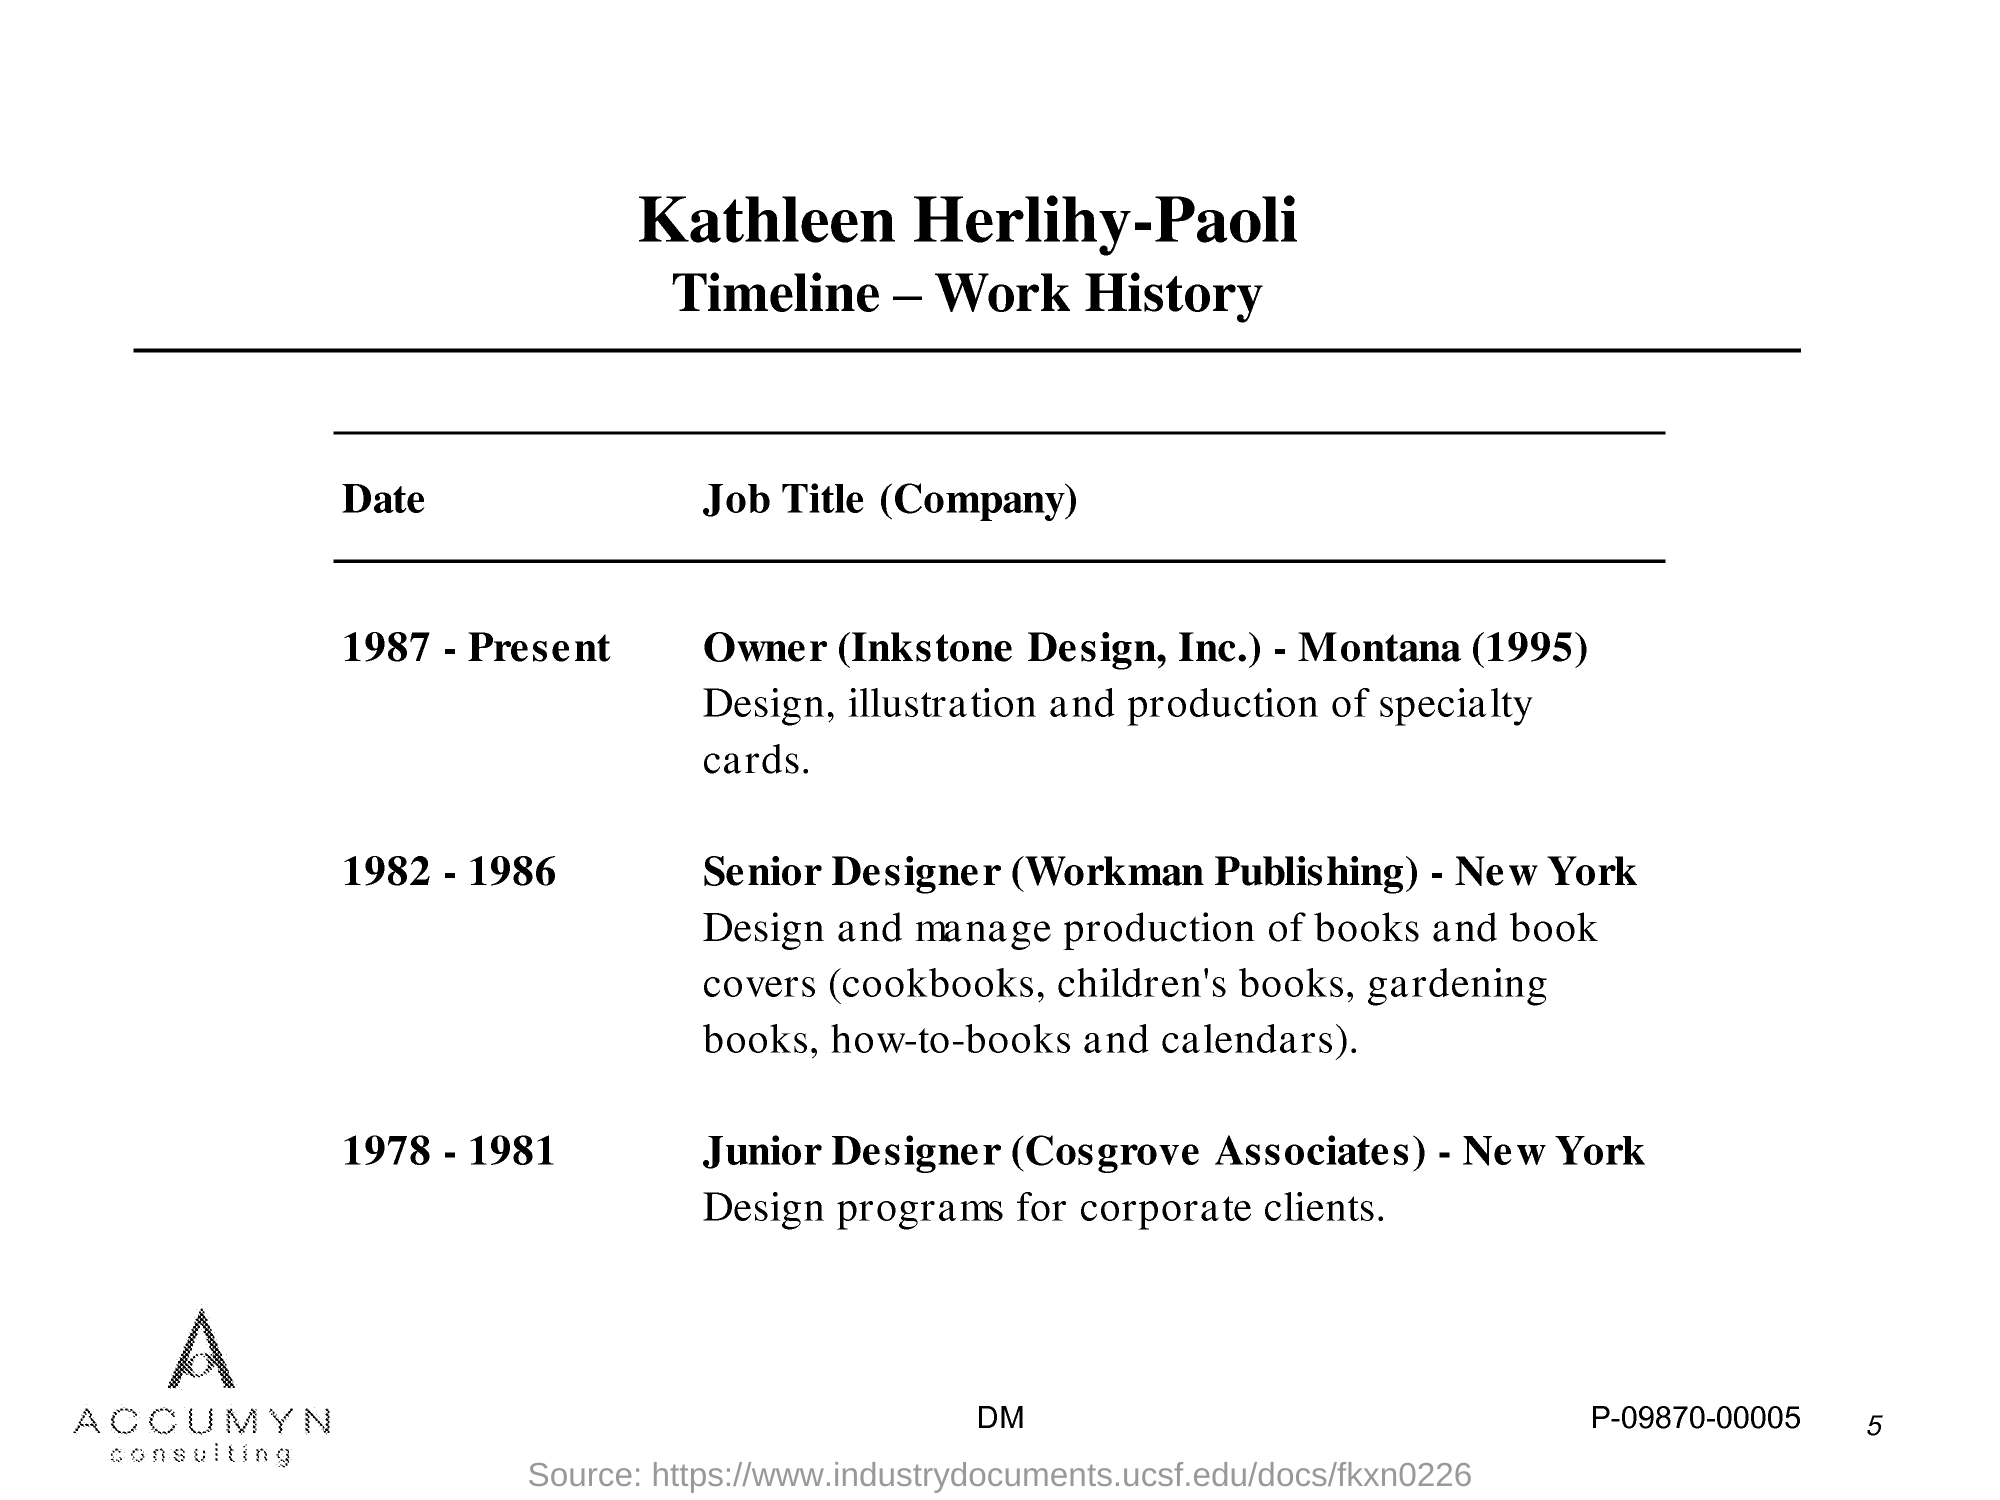Who's Timeline - Wok History is given here?
Provide a succinct answer. Kathleen Herlihy-Paoli. During which year, Kathleen Herlihy-Paoli worked as a senior designer in Workman Publishing, New York?
Provide a short and direct response. 1982-1986. What was the job responsibility of Kathleen Herlihy-Paoli as a Junior Designer in Cosgrove Associates?
Your answer should be compact. Design programs for corporate clients. What is the current position of Kathleen Herlihy-Paoli?
Make the answer very short. Owner (Inkstone Design, Inc.) - Montana (1995). 